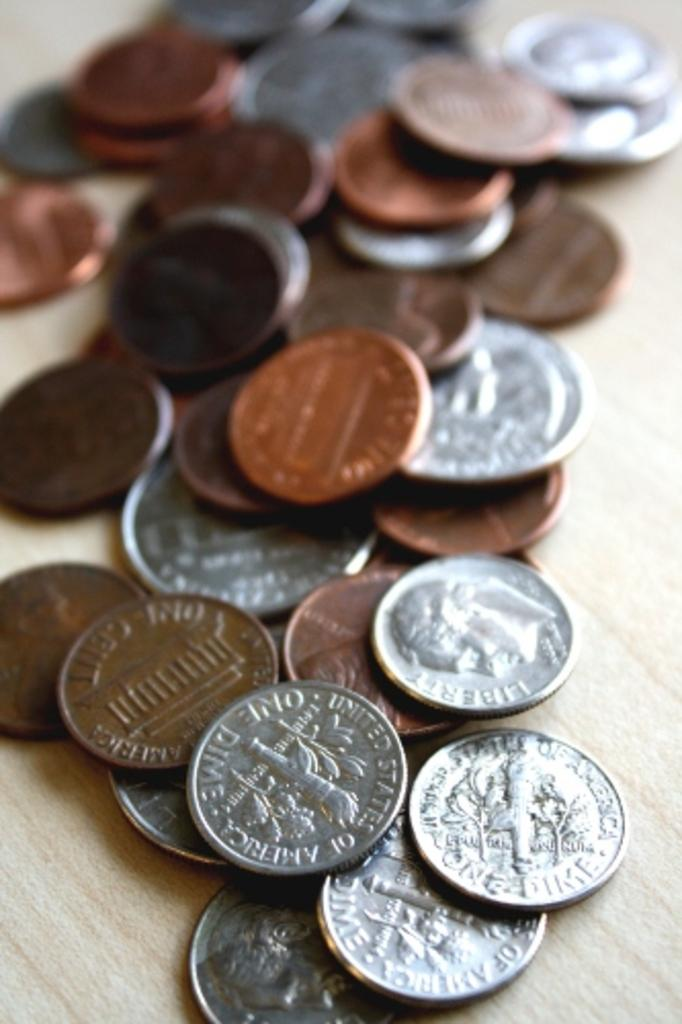<image>
Summarize the visual content of the image. Pile of coins including ones that say one dime 